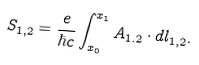<formula> <loc_0><loc_0><loc_500><loc_500>S _ { 1 , 2 } = \frac { e } { \hbar { c } } \int _ { x _ { 0 } } ^ { x _ { 1 } } A _ { 1 . 2 } \cdot d l _ { 1 , 2 } .</formula> 